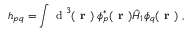Convert formula to latex. <formula><loc_0><loc_0><loc_500><loc_500>h _ { p q } = \int d ^ { 3 } ( r ) \, \phi _ { p } ^ { * } ( r ) \hat { H } _ { 1 } \phi _ { q } ( r ) ,</formula> 